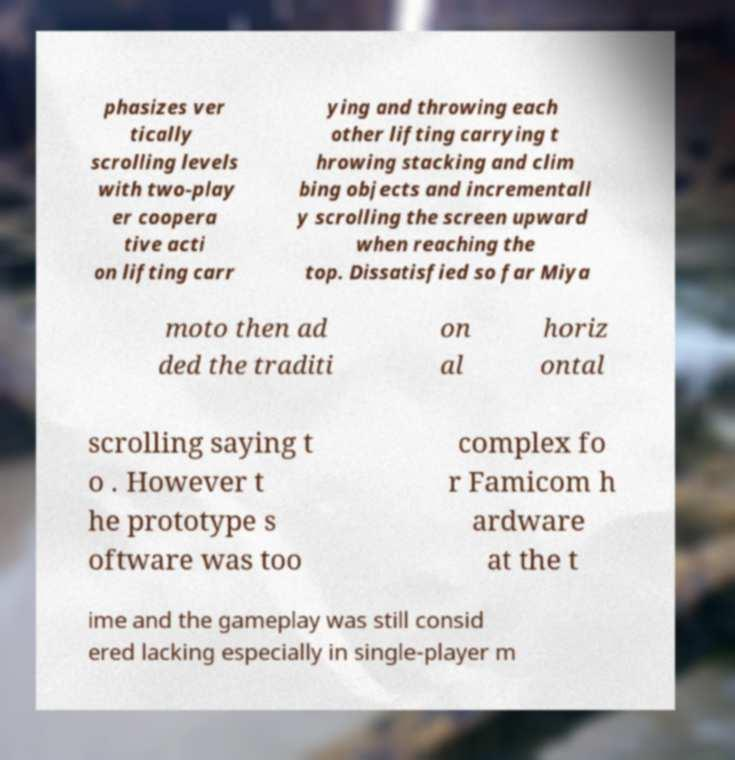For documentation purposes, I need the text within this image transcribed. Could you provide that? phasizes ver tically scrolling levels with two-play er coopera tive acti on lifting carr ying and throwing each other lifting carrying t hrowing stacking and clim bing objects and incrementall y scrolling the screen upward when reaching the top. Dissatisfied so far Miya moto then ad ded the traditi on al horiz ontal scrolling saying t o . However t he prototype s oftware was too complex fo r Famicom h ardware at the t ime and the gameplay was still consid ered lacking especially in single-player m 